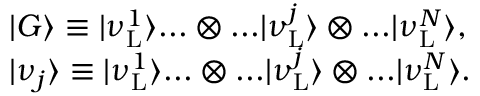Convert formula to latex. <formula><loc_0><loc_0><loc_500><loc_500>\begin{array} { r l } & { | G \rangle \equiv | \nu _ { L } ^ { 1 } \rangle \dots \otimes \dots | \nu _ { L } ^ { j } \rangle \otimes \dots | \nu _ { L } ^ { N } \rangle , } \\ & { | \nu _ { j } \rangle \equiv | \nu _ { L } ^ { 1 } \rangle \dots \otimes \dots | \nu _ { L } ^ { j } \rangle \otimes \dots | \nu _ { L } ^ { N } \rangle . } \end{array}</formula> 